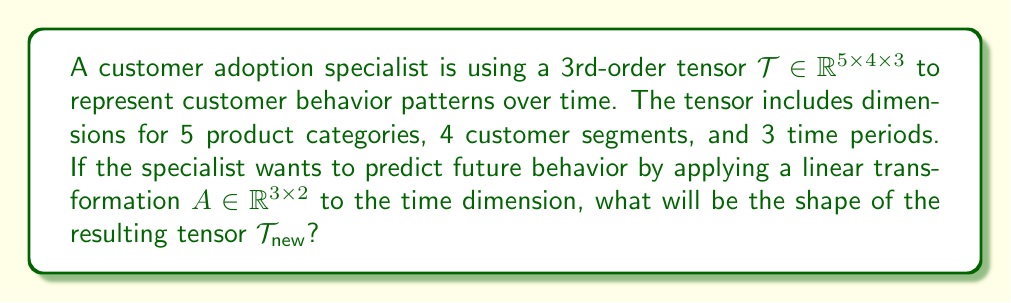Help me with this question. To solve this problem, we need to understand how tensor operations work, specifically mode-n product multiplication. Here's a step-by-step explanation:

1) The original tensor $\mathcal{T}$ has dimensions $5 \times 4 \times 3$.

2) The linear transformation $A$ is applied to the third mode (time dimension) of the tensor.

3) In tensor algebra, this operation is known as the mode-3 product, denoted as $\mathcal{T} \times_3 A$.

4) When performing a mode-n product between a tensor and a matrix, the result is a new tensor where:
   - The nth dimension of the original tensor is replaced by the number of columns in the matrix.
   - All other dimensions remain the same.

5) In this case:
   - The 3rd dimension (originally 3) will be replaced by the number of columns in $A$, which is 2.
   - The 1st and 2nd dimensions (5 and 4 respectively) remain unchanged.

6) Therefore, the resulting tensor $\mathcal{T}_{\text{new}}$ will have dimensions $5 \times 4 \times 2$.
Answer: $5 \times 4 \times 2$ 